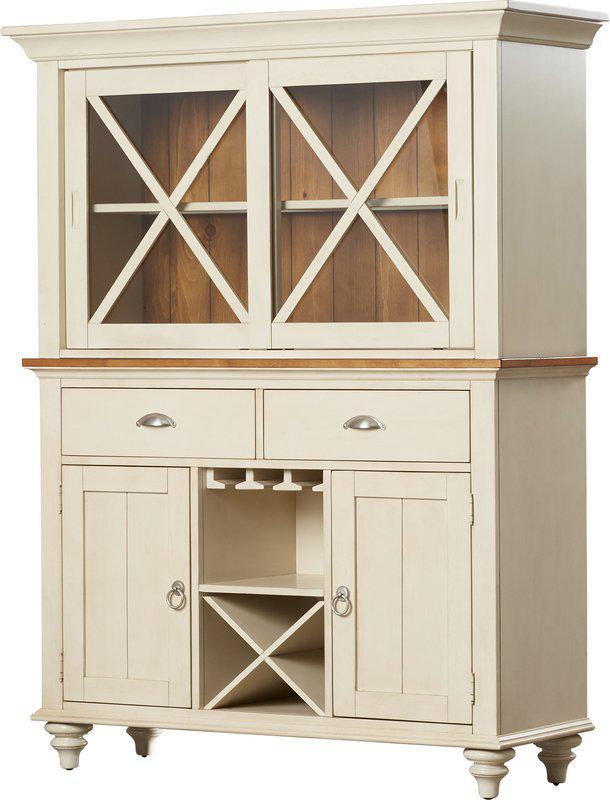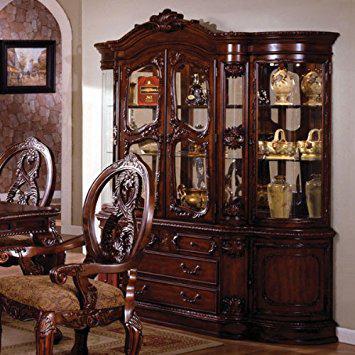The first image is the image on the left, the second image is the image on the right. Analyze the images presented: Is the assertion "A brown hutch is empty in the right image." valid? Answer yes or no. No. The first image is the image on the left, the second image is the image on the right. Examine the images to the left and right. Is the description "A brown wood cabinet has slender legs and arch shapes on the glass-fronted cabinet doors." accurate? Answer yes or no. No. 